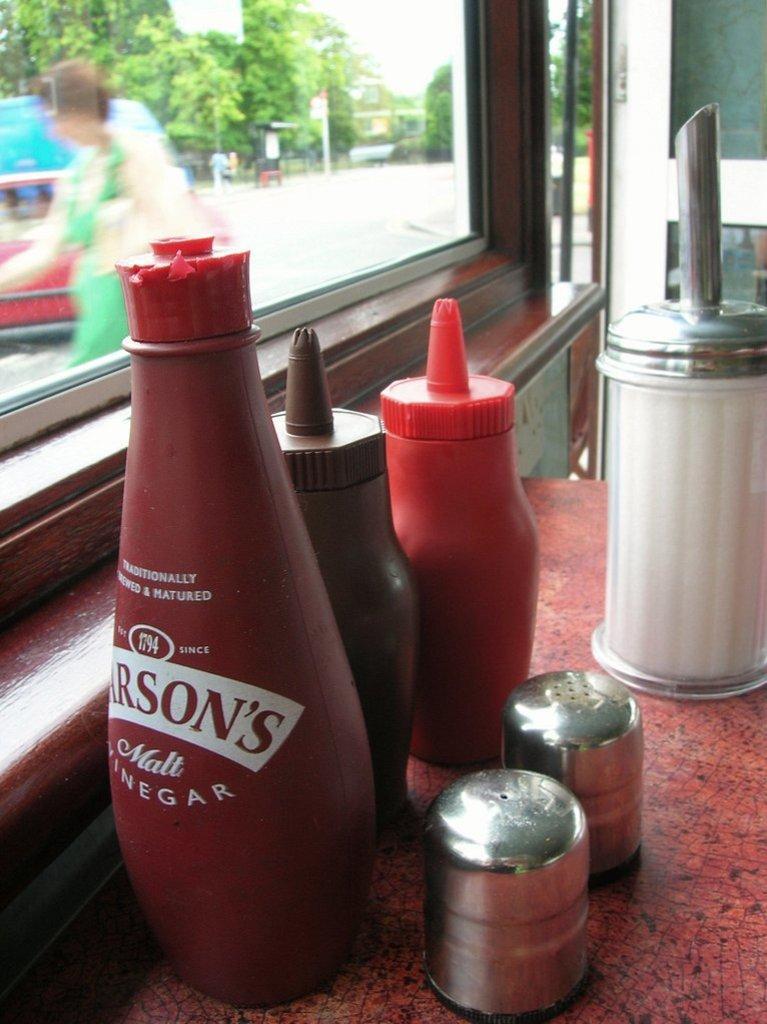Describe this image in one or two sentences. This bottles are highlighted in this picture. On this table there are different type of bottles. Outside of this window we can able to see a person and number of trees. 